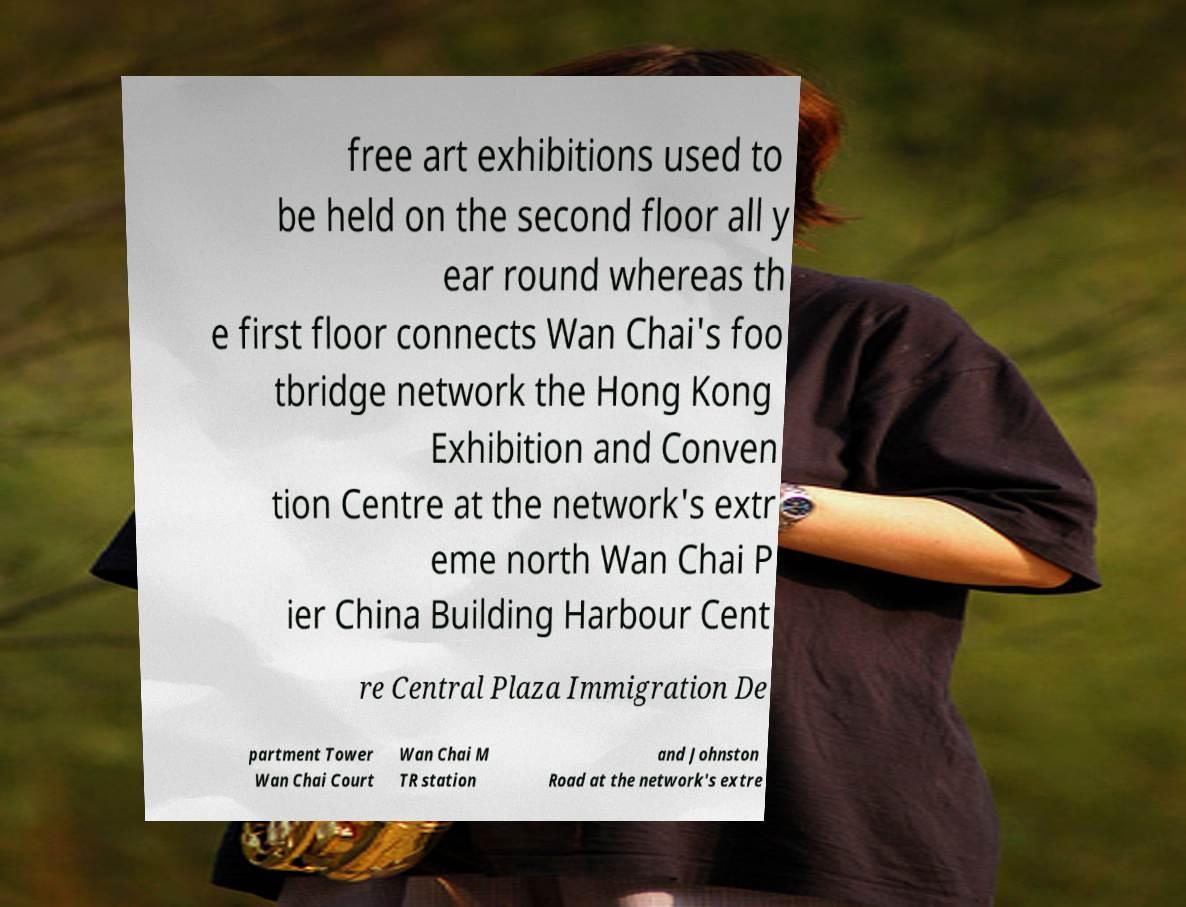I need the written content from this picture converted into text. Can you do that? free art exhibitions used to be held on the second floor all y ear round whereas th e first floor connects Wan Chai's foo tbridge network the Hong Kong Exhibition and Conven tion Centre at the network's extr eme north Wan Chai P ier China Building Harbour Cent re Central Plaza Immigration De partment Tower Wan Chai Court Wan Chai M TR station and Johnston Road at the network's extre 